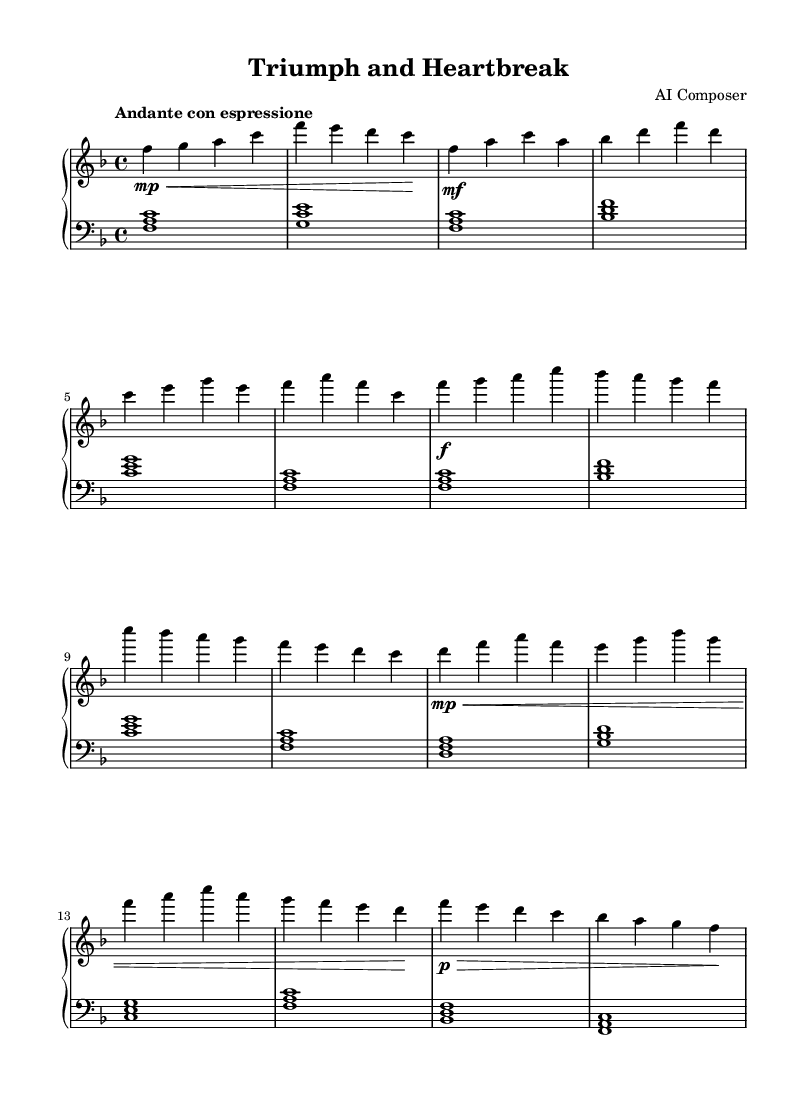What is the key signature of this music? The key signature is F major, which contains one flat (B flat).
Answer: F major What is the time signature of this music? The time signature is 4/4, indicating four beats in each measure and a quarter note gets one beat.
Answer: 4/4 What is the tempo marking of this music? The tempo marking is "Andante con espressione," indicating a moderately slow pace with expression.
Answer: Andante con espressione How many sections are there in the piece? The piece has five distinct sections: Intro, Verse, Chorus, Bridge, and Outro.
Answer: Five What is the dynamics for the chorus section? The dynamics for the chorus section start at fortissimo, indicating a loud and powerful expression.
Answer: Fortissimo Which section features a softer dynamic at the beginning? The "Bridge" section features a softer dynamic at the beginning, indicated by the "mp" marking.
Answer: Bridge Which musical elements are commonly found in Romantic ballads as depicted in this piece? The piece features expressive dynamics, lyrical melodies, and harmonic progressions typical of Romantic ballads.
Answer: Expressive dynamics 